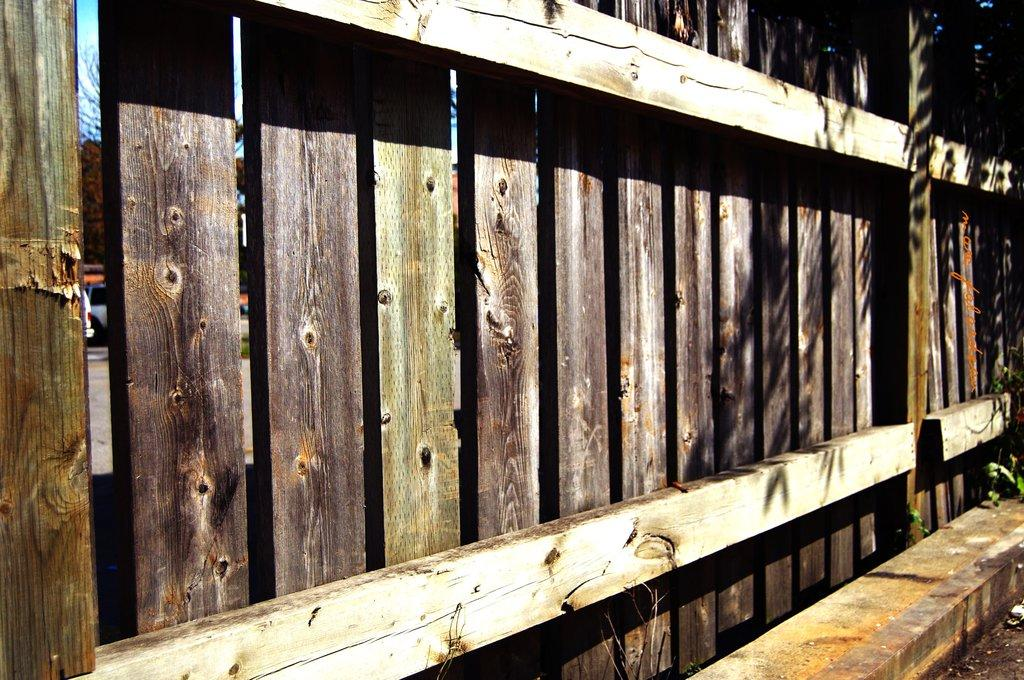What type of barrier is present in the image? There is a wooden fence in the image. What can be seen beyond the fence? Vehicles, a tree, and the sky are visible through the fence. What type of pet is sitting on the screw in the image? There is no pet or screw present in the image. 